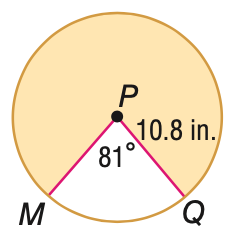Question: Find the area of the shaded sector. Round to the nearest tenth, if necessary.
Choices:
A. 15.3
B. 52.6
C. 82.4
D. 284.0
Answer with the letter. Answer: D 